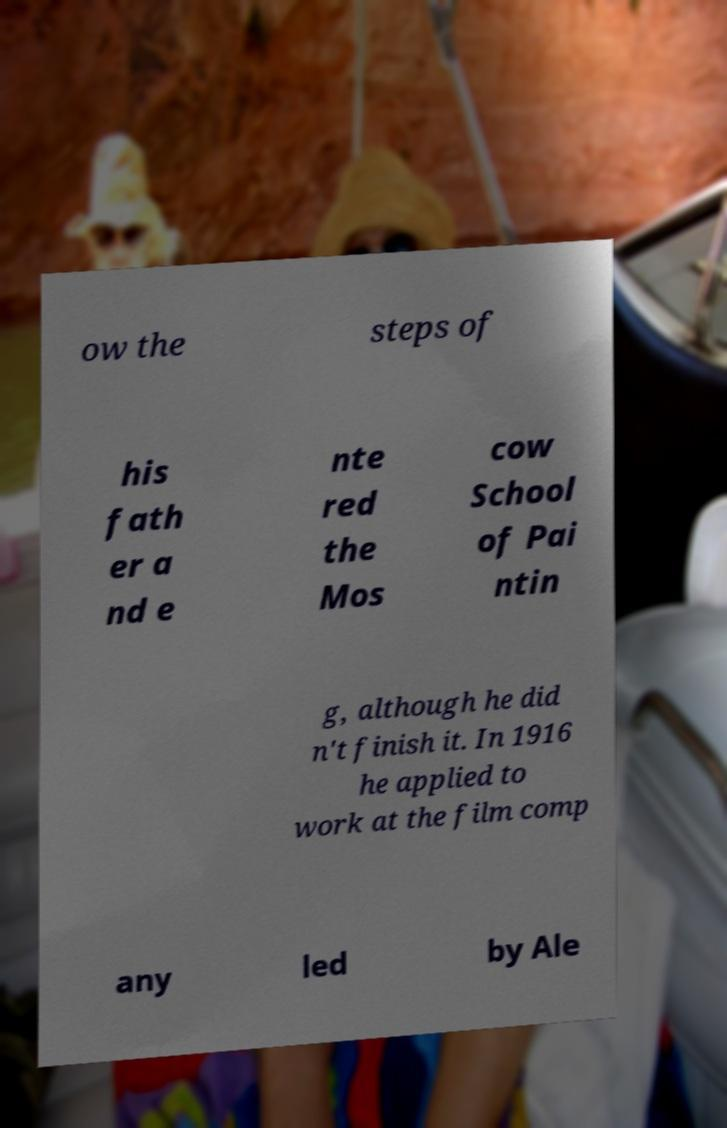Please identify and transcribe the text found in this image. ow the steps of his fath er a nd e nte red the Mos cow School of Pai ntin g, although he did n't finish it. In 1916 he applied to work at the film comp any led by Ale 